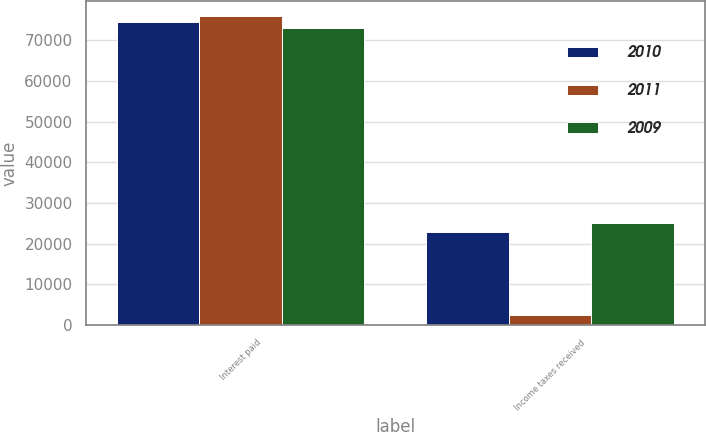Convert chart. <chart><loc_0><loc_0><loc_500><loc_500><stacked_bar_chart><ecel><fcel>Interest paid<fcel>Income taxes received<nl><fcel>2010<fcel>74569<fcel>22893<nl><fcel>2011<fcel>75909<fcel>2379<nl><fcel>2009<fcel>73031<fcel>25202<nl></chart> 